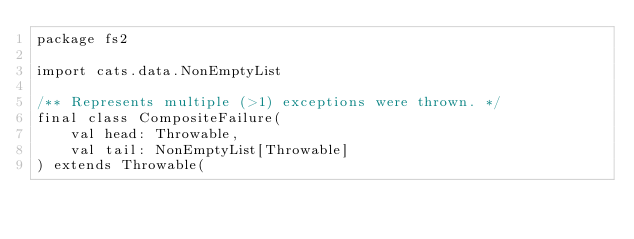<code> <loc_0><loc_0><loc_500><loc_500><_Scala_>package fs2

import cats.data.NonEmptyList

/** Represents multiple (>1) exceptions were thrown. */
final class CompositeFailure(
    val head: Throwable,
    val tail: NonEmptyList[Throwable]
) extends Throwable(</code> 